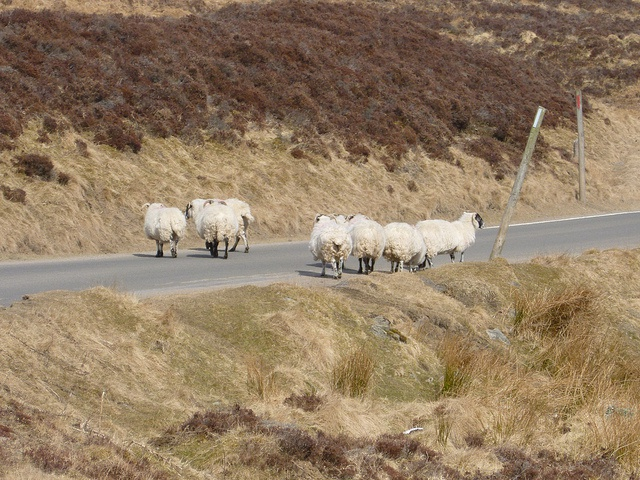Describe the objects in this image and their specific colors. I can see sheep in gray, lightgray, and darkgray tones, sheep in gray, lightgray, and darkgray tones, sheep in gray, lightgray, darkgray, and tan tones, sheep in gray, lightgray, tan, and darkgray tones, and sheep in gray, lightgray, tan, and darkgray tones in this image. 